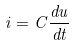<formula> <loc_0><loc_0><loc_500><loc_500>i = C \frac { d u } { d t }</formula> 